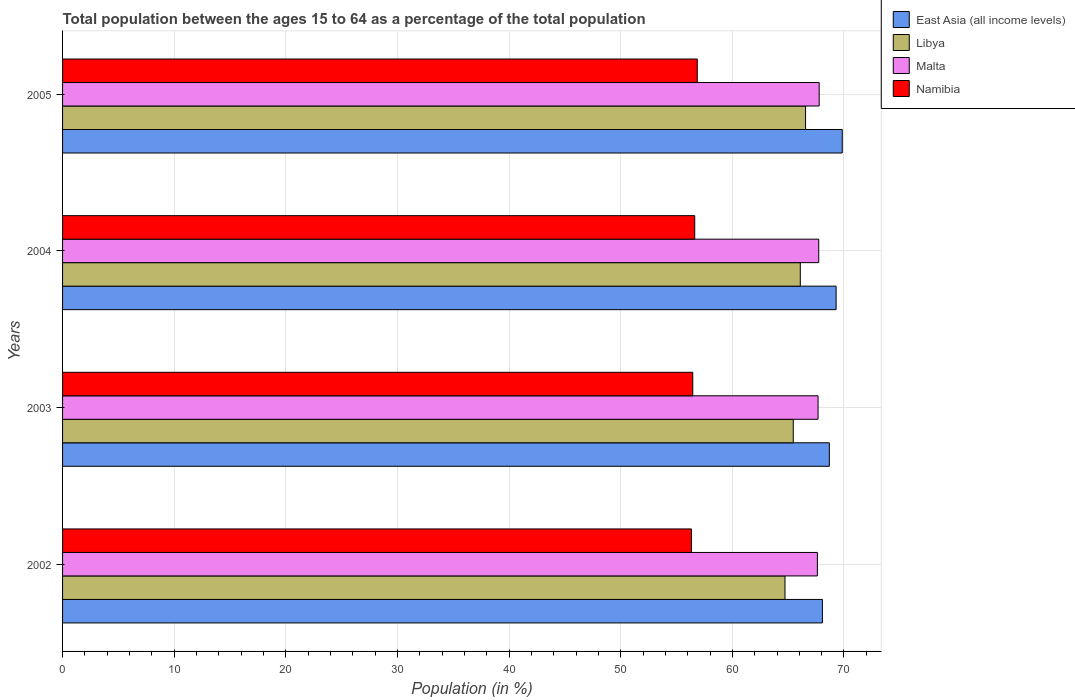How many groups of bars are there?
Give a very brief answer. 4. Are the number of bars per tick equal to the number of legend labels?
Your answer should be very brief. Yes. Are the number of bars on each tick of the Y-axis equal?
Make the answer very short. Yes. In how many cases, is the number of bars for a given year not equal to the number of legend labels?
Keep it short and to the point. 0. What is the percentage of the population ages 15 to 64 in Malta in 2005?
Your answer should be compact. 67.78. Across all years, what is the maximum percentage of the population ages 15 to 64 in East Asia (all income levels)?
Offer a very short reply. 69.85. Across all years, what is the minimum percentage of the population ages 15 to 64 in Namibia?
Ensure brevity in your answer.  56.34. What is the total percentage of the population ages 15 to 64 in Namibia in the graph?
Give a very brief answer. 226.28. What is the difference between the percentage of the population ages 15 to 64 in Malta in 2003 and that in 2004?
Offer a terse response. -0.06. What is the difference between the percentage of the population ages 15 to 64 in Namibia in 2003 and the percentage of the population ages 15 to 64 in Malta in 2002?
Offer a very short reply. -11.16. What is the average percentage of the population ages 15 to 64 in East Asia (all income levels) per year?
Provide a short and direct response. 68.98. In the year 2005, what is the difference between the percentage of the population ages 15 to 64 in Namibia and percentage of the population ages 15 to 64 in Malta?
Ensure brevity in your answer.  -10.92. In how many years, is the percentage of the population ages 15 to 64 in Libya greater than 14 ?
Make the answer very short. 4. What is the ratio of the percentage of the population ages 15 to 64 in Namibia in 2002 to that in 2004?
Make the answer very short. 0.99. Is the percentage of the population ages 15 to 64 in Libya in 2003 less than that in 2005?
Give a very brief answer. Yes. Is the difference between the percentage of the population ages 15 to 64 in Namibia in 2002 and 2004 greater than the difference between the percentage of the population ages 15 to 64 in Malta in 2002 and 2004?
Ensure brevity in your answer.  No. What is the difference between the highest and the second highest percentage of the population ages 15 to 64 in Libya?
Give a very brief answer. 0.47. What is the difference between the highest and the lowest percentage of the population ages 15 to 64 in Malta?
Provide a short and direct response. 0.16. What does the 1st bar from the top in 2003 represents?
Keep it short and to the point. Namibia. What does the 2nd bar from the bottom in 2003 represents?
Provide a succinct answer. Libya. How many bars are there?
Provide a short and direct response. 16. Are all the bars in the graph horizontal?
Give a very brief answer. Yes. What is the difference between two consecutive major ticks on the X-axis?
Offer a terse response. 10. Are the values on the major ticks of X-axis written in scientific E-notation?
Your answer should be compact. No. Does the graph contain any zero values?
Offer a very short reply. No. Does the graph contain grids?
Provide a succinct answer. Yes. Where does the legend appear in the graph?
Offer a very short reply. Top right. How many legend labels are there?
Offer a terse response. 4. What is the title of the graph?
Provide a succinct answer. Total population between the ages 15 to 64 as a percentage of the total population. Does "Peru" appear as one of the legend labels in the graph?
Keep it short and to the point. No. What is the Population (in %) in East Asia (all income levels) in 2002?
Give a very brief answer. 68.07. What is the Population (in %) of Libya in 2002?
Offer a terse response. 64.72. What is the Population (in %) in Malta in 2002?
Offer a terse response. 67.62. What is the Population (in %) of Namibia in 2002?
Offer a very short reply. 56.34. What is the Population (in %) in East Asia (all income levels) in 2003?
Provide a short and direct response. 68.69. What is the Population (in %) of Libya in 2003?
Your answer should be compact. 65.46. What is the Population (in %) of Malta in 2003?
Your answer should be compact. 67.68. What is the Population (in %) of Namibia in 2003?
Your answer should be very brief. 56.45. What is the Population (in %) of East Asia (all income levels) in 2004?
Your answer should be compact. 69.3. What is the Population (in %) in Libya in 2004?
Keep it short and to the point. 66.09. What is the Population (in %) of Malta in 2004?
Provide a short and direct response. 67.74. What is the Population (in %) of Namibia in 2004?
Your response must be concise. 56.63. What is the Population (in %) of East Asia (all income levels) in 2005?
Provide a short and direct response. 69.85. What is the Population (in %) in Libya in 2005?
Give a very brief answer. 66.56. What is the Population (in %) in Malta in 2005?
Make the answer very short. 67.78. What is the Population (in %) in Namibia in 2005?
Keep it short and to the point. 56.86. Across all years, what is the maximum Population (in %) of East Asia (all income levels)?
Ensure brevity in your answer.  69.85. Across all years, what is the maximum Population (in %) in Libya?
Ensure brevity in your answer.  66.56. Across all years, what is the maximum Population (in %) in Malta?
Provide a short and direct response. 67.78. Across all years, what is the maximum Population (in %) of Namibia?
Give a very brief answer. 56.86. Across all years, what is the minimum Population (in %) in East Asia (all income levels)?
Ensure brevity in your answer.  68.07. Across all years, what is the minimum Population (in %) in Libya?
Ensure brevity in your answer.  64.72. Across all years, what is the minimum Population (in %) of Malta?
Offer a terse response. 67.62. Across all years, what is the minimum Population (in %) of Namibia?
Keep it short and to the point. 56.34. What is the total Population (in %) in East Asia (all income levels) in the graph?
Make the answer very short. 275.9. What is the total Population (in %) in Libya in the graph?
Give a very brief answer. 262.82. What is the total Population (in %) of Malta in the graph?
Provide a short and direct response. 270.82. What is the total Population (in %) of Namibia in the graph?
Keep it short and to the point. 226.28. What is the difference between the Population (in %) of East Asia (all income levels) in 2002 and that in 2003?
Make the answer very short. -0.62. What is the difference between the Population (in %) in Libya in 2002 and that in 2003?
Provide a succinct answer. -0.74. What is the difference between the Population (in %) of Malta in 2002 and that in 2003?
Your answer should be compact. -0.06. What is the difference between the Population (in %) in Namibia in 2002 and that in 2003?
Offer a terse response. -0.12. What is the difference between the Population (in %) in East Asia (all income levels) in 2002 and that in 2004?
Your response must be concise. -1.23. What is the difference between the Population (in %) in Libya in 2002 and that in 2004?
Offer a very short reply. -1.37. What is the difference between the Population (in %) in Malta in 2002 and that in 2004?
Provide a short and direct response. -0.12. What is the difference between the Population (in %) of Namibia in 2002 and that in 2004?
Keep it short and to the point. -0.29. What is the difference between the Population (in %) of East Asia (all income levels) in 2002 and that in 2005?
Keep it short and to the point. -1.78. What is the difference between the Population (in %) of Libya in 2002 and that in 2005?
Offer a very short reply. -1.84. What is the difference between the Population (in %) in Malta in 2002 and that in 2005?
Provide a succinct answer. -0.16. What is the difference between the Population (in %) in Namibia in 2002 and that in 2005?
Your response must be concise. -0.52. What is the difference between the Population (in %) in East Asia (all income levels) in 2003 and that in 2004?
Your response must be concise. -0.61. What is the difference between the Population (in %) in Libya in 2003 and that in 2004?
Provide a succinct answer. -0.63. What is the difference between the Population (in %) of Malta in 2003 and that in 2004?
Provide a succinct answer. -0.06. What is the difference between the Population (in %) in Namibia in 2003 and that in 2004?
Ensure brevity in your answer.  -0.18. What is the difference between the Population (in %) in East Asia (all income levels) in 2003 and that in 2005?
Your answer should be very brief. -1.16. What is the difference between the Population (in %) in Libya in 2003 and that in 2005?
Keep it short and to the point. -1.1. What is the difference between the Population (in %) in Malta in 2003 and that in 2005?
Provide a short and direct response. -0.1. What is the difference between the Population (in %) of Namibia in 2003 and that in 2005?
Your answer should be compact. -0.4. What is the difference between the Population (in %) of East Asia (all income levels) in 2004 and that in 2005?
Ensure brevity in your answer.  -0.55. What is the difference between the Population (in %) of Libya in 2004 and that in 2005?
Offer a very short reply. -0.47. What is the difference between the Population (in %) in Malta in 2004 and that in 2005?
Your answer should be compact. -0.04. What is the difference between the Population (in %) in Namibia in 2004 and that in 2005?
Give a very brief answer. -0.23. What is the difference between the Population (in %) in East Asia (all income levels) in 2002 and the Population (in %) in Libya in 2003?
Provide a short and direct response. 2.61. What is the difference between the Population (in %) of East Asia (all income levels) in 2002 and the Population (in %) of Malta in 2003?
Provide a succinct answer. 0.39. What is the difference between the Population (in %) in East Asia (all income levels) in 2002 and the Population (in %) in Namibia in 2003?
Your answer should be compact. 11.61. What is the difference between the Population (in %) of Libya in 2002 and the Population (in %) of Malta in 2003?
Make the answer very short. -2.96. What is the difference between the Population (in %) of Libya in 2002 and the Population (in %) of Namibia in 2003?
Give a very brief answer. 8.26. What is the difference between the Population (in %) of Malta in 2002 and the Population (in %) of Namibia in 2003?
Offer a terse response. 11.16. What is the difference between the Population (in %) of East Asia (all income levels) in 2002 and the Population (in %) of Libya in 2004?
Offer a terse response. 1.98. What is the difference between the Population (in %) in East Asia (all income levels) in 2002 and the Population (in %) in Malta in 2004?
Provide a short and direct response. 0.33. What is the difference between the Population (in %) of East Asia (all income levels) in 2002 and the Population (in %) of Namibia in 2004?
Offer a terse response. 11.44. What is the difference between the Population (in %) in Libya in 2002 and the Population (in %) in Malta in 2004?
Offer a terse response. -3.02. What is the difference between the Population (in %) in Libya in 2002 and the Population (in %) in Namibia in 2004?
Provide a short and direct response. 8.08. What is the difference between the Population (in %) in Malta in 2002 and the Population (in %) in Namibia in 2004?
Provide a short and direct response. 10.99. What is the difference between the Population (in %) in East Asia (all income levels) in 2002 and the Population (in %) in Libya in 2005?
Provide a short and direct response. 1.51. What is the difference between the Population (in %) of East Asia (all income levels) in 2002 and the Population (in %) of Malta in 2005?
Provide a succinct answer. 0.29. What is the difference between the Population (in %) of East Asia (all income levels) in 2002 and the Population (in %) of Namibia in 2005?
Give a very brief answer. 11.21. What is the difference between the Population (in %) in Libya in 2002 and the Population (in %) in Malta in 2005?
Give a very brief answer. -3.06. What is the difference between the Population (in %) in Libya in 2002 and the Population (in %) in Namibia in 2005?
Keep it short and to the point. 7.86. What is the difference between the Population (in %) of Malta in 2002 and the Population (in %) of Namibia in 2005?
Your answer should be very brief. 10.76. What is the difference between the Population (in %) of East Asia (all income levels) in 2003 and the Population (in %) of Libya in 2004?
Provide a short and direct response. 2.6. What is the difference between the Population (in %) in East Asia (all income levels) in 2003 and the Population (in %) in Malta in 2004?
Your answer should be compact. 0.95. What is the difference between the Population (in %) of East Asia (all income levels) in 2003 and the Population (in %) of Namibia in 2004?
Keep it short and to the point. 12.06. What is the difference between the Population (in %) in Libya in 2003 and the Population (in %) in Malta in 2004?
Offer a terse response. -2.28. What is the difference between the Population (in %) in Libya in 2003 and the Population (in %) in Namibia in 2004?
Your response must be concise. 8.83. What is the difference between the Population (in %) in Malta in 2003 and the Population (in %) in Namibia in 2004?
Keep it short and to the point. 11.05. What is the difference between the Population (in %) of East Asia (all income levels) in 2003 and the Population (in %) of Libya in 2005?
Provide a short and direct response. 2.13. What is the difference between the Population (in %) of East Asia (all income levels) in 2003 and the Population (in %) of Malta in 2005?
Offer a terse response. 0.91. What is the difference between the Population (in %) of East Asia (all income levels) in 2003 and the Population (in %) of Namibia in 2005?
Give a very brief answer. 11.83. What is the difference between the Population (in %) of Libya in 2003 and the Population (in %) of Malta in 2005?
Provide a short and direct response. -2.32. What is the difference between the Population (in %) in Libya in 2003 and the Population (in %) in Namibia in 2005?
Make the answer very short. 8.6. What is the difference between the Population (in %) of Malta in 2003 and the Population (in %) of Namibia in 2005?
Give a very brief answer. 10.82. What is the difference between the Population (in %) in East Asia (all income levels) in 2004 and the Population (in %) in Libya in 2005?
Provide a succinct answer. 2.74. What is the difference between the Population (in %) of East Asia (all income levels) in 2004 and the Population (in %) of Malta in 2005?
Ensure brevity in your answer.  1.52. What is the difference between the Population (in %) in East Asia (all income levels) in 2004 and the Population (in %) in Namibia in 2005?
Your answer should be compact. 12.44. What is the difference between the Population (in %) of Libya in 2004 and the Population (in %) of Malta in 2005?
Provide a short and direct response. -1.69. What is the difference between the Population (in %) of Libya in 2004 and the Population (in %) of Namibia in 2005?
Offer a very short reply. 9.23. What is the difference between the Population (in %) in Malta in 2004 and the Population (in %) in Namibia in 2005?
Offer a terse response. 10.88. What is the average Population (in %) of East Asia (all income levels) per year?
Give a very brief answer. 68.98. What is the average Population (in %) in Libya per year?
Provide a short and direct response. 65.7. What is the average Population (in %) of Malta per year?
Your answer should be very brief. 67.7. What is the average Population (in %) in Namibia per year?
Provide a succinct answer. 56.57. In the year 2002, what is the difference between the Population (in %) in East Asia (all income levels) and Population (in %) in Libya?
Provide a short and direct response. 3.35. In the year 2002, what is the difference between the Population (in %) of East Asia (all income levels) and Population (in %) of Malta?
Your answer should be very brief. 0.45. In the year 2002, what is the difference between the Population (in %) in East Asia (all income levels) and Population (in %) in Namibia?
Make the answer very short. 11.73. In the year 2002, what is the difference between the Population (in %) in Libya and Population (in %) in Malta?
Make the answer very short. -2.9. In the year 2002, what is the difference between the Population (in %) of Libya and Population (in %) of Namibia?
Provide a short and direct response. 8.38. In the year 2002, what is the difference between the Population (in %) in Malta and Population (in %) in Namibia?
Your answer should be compact. 11.28. In the year 2003, what is the difference between the Population (in %) in East Asia (all income levels) and Population (in %) in Libya?
Keep it short and to the point. 3.23. In the year 2003, what is the difference between the Population (in %) of East Asia (all income levels) and Population (in %) of Malta?
Your response must be concise. 1.01. In the year 2003, what is the difference between the Population (in %) of East Asia (all income levels) and Population (in %) of Namibia?
Offer a very short reply. 12.23. In the year 2003, what is the difference between the Population (in %) in Libya and Population (in %) in Malta?
Your answer should be very brief. -2.22. In the year 2003, what is the difference between the Population (in %) in Libya and Population (in %) in Namibia?
Your answer should be compact. 9. In the year 2003, what is the difference between the Population (in %) of Malta and Population (in %) of Namibia?
Offer a very short reply. 11.22. In the year 2004, what is the difference between the Population (in %) in East Asia (all income levels) and Population (in %) in Libya?
Make the answer very short. 3.21. In the year 2004, what is the difference between the Population (in %) of East Asia (all income levels) and Population (in %) of Malta?
Keep it short and to the point. 1.56. In the year 2004, what is the difference between the Population (in %) in East Asia (all income levels) and Population (in %) in Namibia?
Offer a very short reply. 12.66. In the year 2004, what is the difference between the Population (in %) of Libya and Population (in %) of Malta?
Your answer should be very brief. -1.65. In the year 2004, what is the difference between the Population (in %) of Libya and Population (in %) of Namibia?
Your answer should be compact. 9.46. In the year 2004, what is the difference between the Population (in %) in Malta and Population (in %) in Namibia?
Provide a succinct answer. 11.11. In the year 2005, what is the difference between the Population (in %) of East Asia (all income levels) and Population (in %) of Libya?
Make the answer very short. 3.29. In the year 2005, what is the difference between the Population (in %) in East Asia (all income levels) and Population (in %) in Malta?
Provide a succinct answer. 2.07. In the year 2005, what is the difference between the Population (in %) of East Asia (all income levels) and Population (in %) of Namibia?
Keep it short and to the point. 12.99. In the year 2005, what is the difference between the Population (in %) of Libya and Population (in %) of Malta?
Give a very brief answer. -1.22. In the year 2005, what is the difference between the Population (in %) in Libya and Population (in %) in Namibia?
Your answer should be compact. 9.7. In the year 2005, what is the difference between the Population (in %) in Malta and Population (in %) in Namibia?
Your answer should be compact. 10.92. What is the ratio of the Population (in %) of East Asia (all income levels) in 2002 to that in 2003?
Provide a succinct answer. 0.99. What is the ratio of the Population (in %) in Libya in 2002 to that in 2003?
Offer a terse response. 0.99. What is the ratio of the Population (in %) of East Asia (all income levels) in 2002 to that in 2004?
Provide a succinct answer. 0.98. What is the ratio of the Population (in %) of Libya in 2002 to that in 2004?
Keep it short and to the point. 0.98. What is the ratio of the Population (in %) in Malta in 2002 to that in 2004?
Offer a very short reply. 1. What is the ratio of the Population (in %) in Namibia in 2002 to that in 2004?
Give a very brief answer. 0.99. What is the ratio of the Population (in %) in East Asia (all income levels) in 2002 to that in 2005?
Your answer should be very brief. 0.97. What is the ratio of the Population (in %) in Libya in 2002 to that in 2005?
Offer a very short reply. 0.97. What is the ratio of the Population (in %) of East Asia (all income levels) in 2003 to that in 2004?
Provide a short and direct response. 0.99. What is the ratio of the Population (in %) of Malta in 2003 to that in 2004?
Offer a terse response. 1. What is the ratio of the Population (in %) of Namibia in 2003 to that in 2004?
Your answer should be very brief. 1. What is the ratio of the Population (in %) of East Asia (all income levels) in 2003 to that in 2005?
Offer a terse response. 0.98. What is the ratio of the Population (in %) in Libya in 2003 to that in 2005?
Offer a terse response. 0.98. What is the ratio of the Population (in %) of East Asia (all income levels) in 2004 to that in 2005?
Your response must be concise. 0.99. What is the ratio of the Population (in %) in Libya in 2004 to that in 2005?
Your answer should be compact. 0.99. What is the ratio of the Population (in %) of Malta in 2004 to that in 2005?
Your answer should be compact. 1. What is the ratio of the Population (in %) in Namibia in 2004 to that in 2005?
Give a very brief answer. 1. What is the difference between the highest and the second highest Population (in %) in East Asia (all income levels)?
Provide a short and direct response. 0.55. What is the difference between the highest and the second highest Population (in %) of Libya?
Provide a succinct answer. 0.47. What is the difference between the highest and the second highest Population (in %) of Malta?
Ensure brevity in your answer.  0.04. What is the difference between the highest and the second highest Population (in %) of Namibia?
Give a very brief answer. 0.23. What is the difference between the highest and the lowest Population (in %) of East Asia (all income levels)?
Keep it short and to the point. 1.78. What is the difference between the highest and the lowest Population (in %) of Libya?
Keep it short and to the point. 1.84. What is the difference between the highest and the lowest Population (in %) in Malta?
Offer a terse response. 0.16. What is the difference between the highest and the lowest Population (in %) of Namibia?
Ensure brevity in your answer.  0.52. 